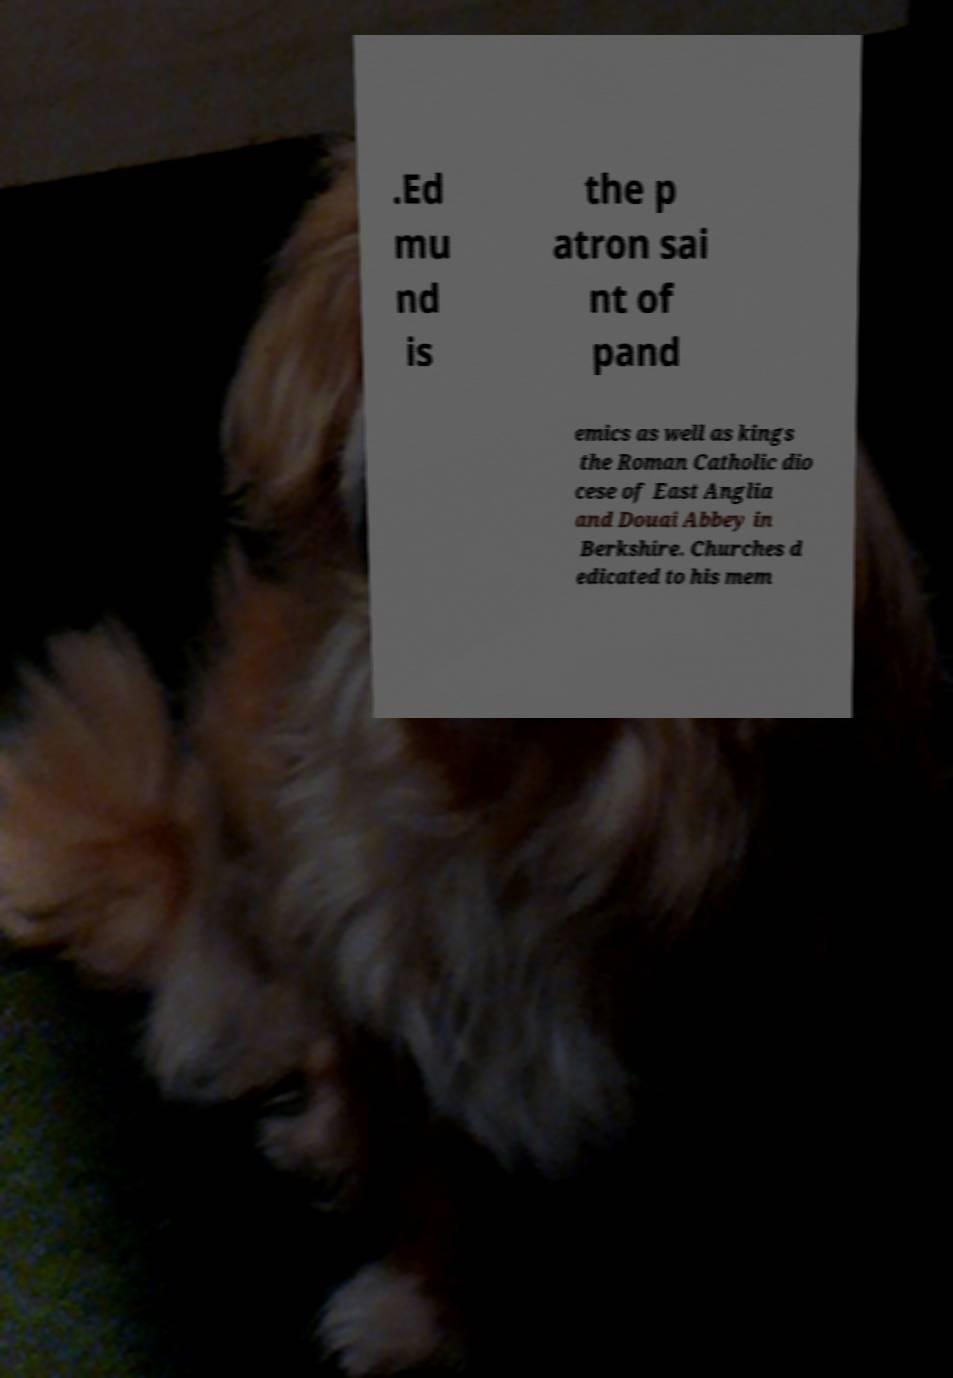Can you read and provide the text displayed in the image?This photo seems to have some interesting text. Can you extract and type it out for me? .Ed mu nd is the p atron sai nt of pand emics as well as kings the Roman Catholic dio cese of East Anglia and Douai Abbey in Berkshire. Churches d edicated to his mem 